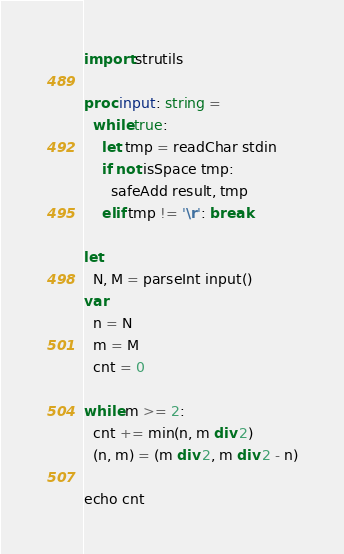<code> <loc_0><loc_0><loc_500><loc_500><_Nim_>import strutils

proc input: string =
  while true:
    let tmp = readChar stdin
    if not isSpace tmp:
      safeAdd result, tmp
    elif tmp != '\r': break

let
  N, M = parseInt input()
var
  n = N
  m = M
  cnt = 0

while m >= 2:
  cnt += min(n, m div 2)
  (n, m) = (m div 2, m div 2 - n)

echo cnt
</code> 